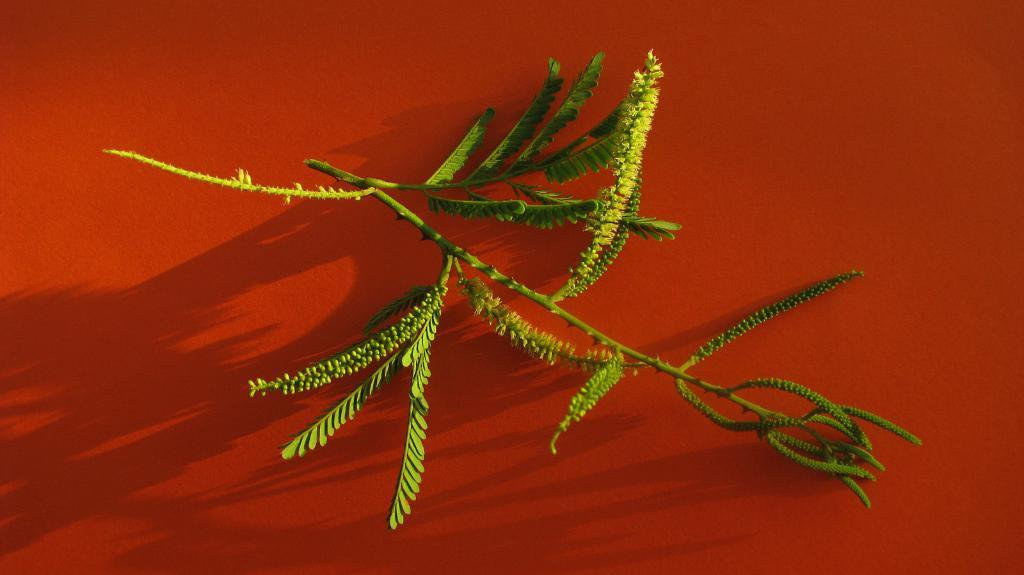What is the main object in the image? There is a branch with leaves in the image. What is the color of the surface the branch is on? The branch is on a red surface. What can be observed under the branch on the red surface? The shadow of the branch is visible on the red surface. What type of trade is happening between the two tanks in the image? There are no tanks present in the image; it features a branch with leaves on a red surface. How many men are visible in the image? There are no men present in the image. 